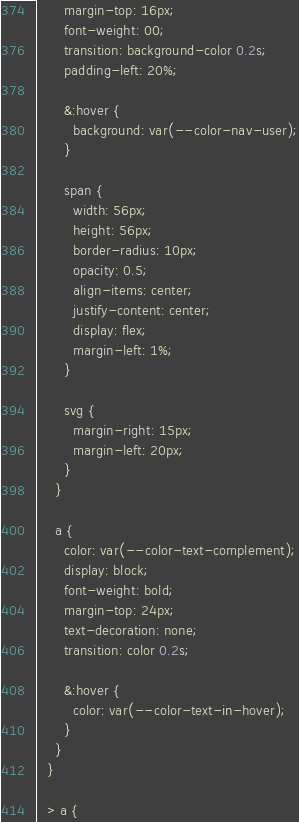Convert code to text. <code><loc_0><loc_0><loc_500><loc_500><_TypeScript_>      margin-top: 16px;
      font-weight: 00;
      transition: background-color 0.2s;
      padding-left: 20%;

      &:hover {
        background: var(--color-nav-user);
      }

      span {
        width: 56px;
        height: 56px;
        border-radius: 10px;
        opacity: 0.5;
        align-items: center;
        justify-content: center;
        display: flex;
        margin-left: 1%;
      }

      svg {
        margin-right: 15px;
        margin-left: 20px;
      }
    }

    a {
      color: var(--color-text-complement);
      display: block;
      font-weight: bold;
      margin-top: 24px;
      text-decoration: none;
      transition: color 0.2s;

      &:hover {
        color: var(--color-text-in-hover);
      }
    }
  }

  > a {</code> 